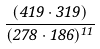<formula> <loc_0><loc_0><loc_500><loc_500>\frac { ( 4 1 9 \cdot 3 1 9 ) } { ( 2 7 8 \cdot 1 8 6 ) ^ { 1 1 } }</formula> 